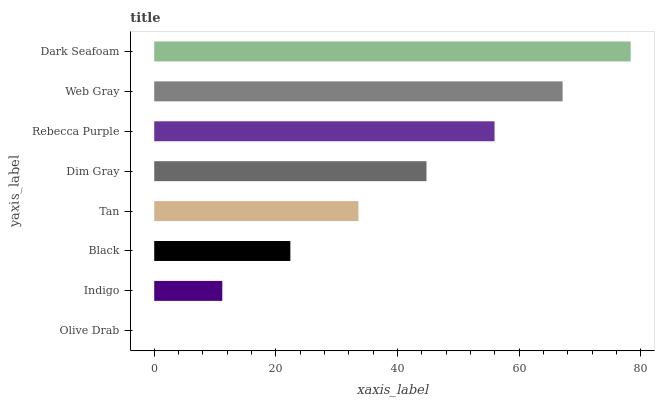Is Olive Drab the minimum?
Answer yes or no. Yes. Is Dark Seafoam the maximum?
Answer yes or no. Yes. Is Indigo the minimum?
Answer yes or no. No. Is Indigo the maximum?
Answer yes or no. No. Is Indigo greater than Olive Drab?
Answer yes or no. Yes. Is Olive Drab less than Indigo?
Answer yes or no. Yes. Is Olive Drab greater than Indigo?
Answer yes or no. No. Is Indigo less than Olive Drab?
Answer yes or no. No. Is Dim Gray the high median?
Answer yes or no. Yes. Is Tan the low median?
Answer yes or no. Yes. Is Olive Drab the high median?
Answer yes or no. No. Is Indigo the low median?
Answer yes or no. No. 